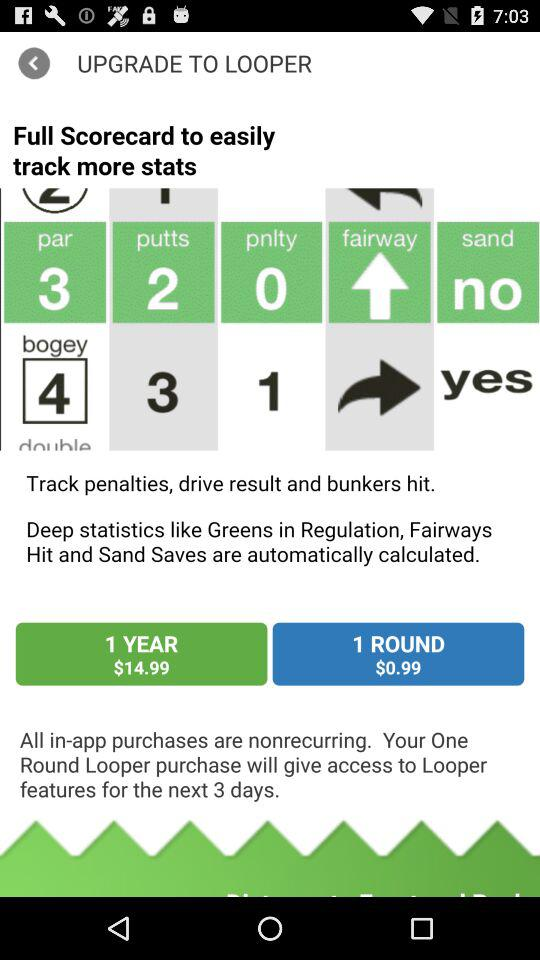What are the charges for 1 round? The charge for 1 round is $0.99. 